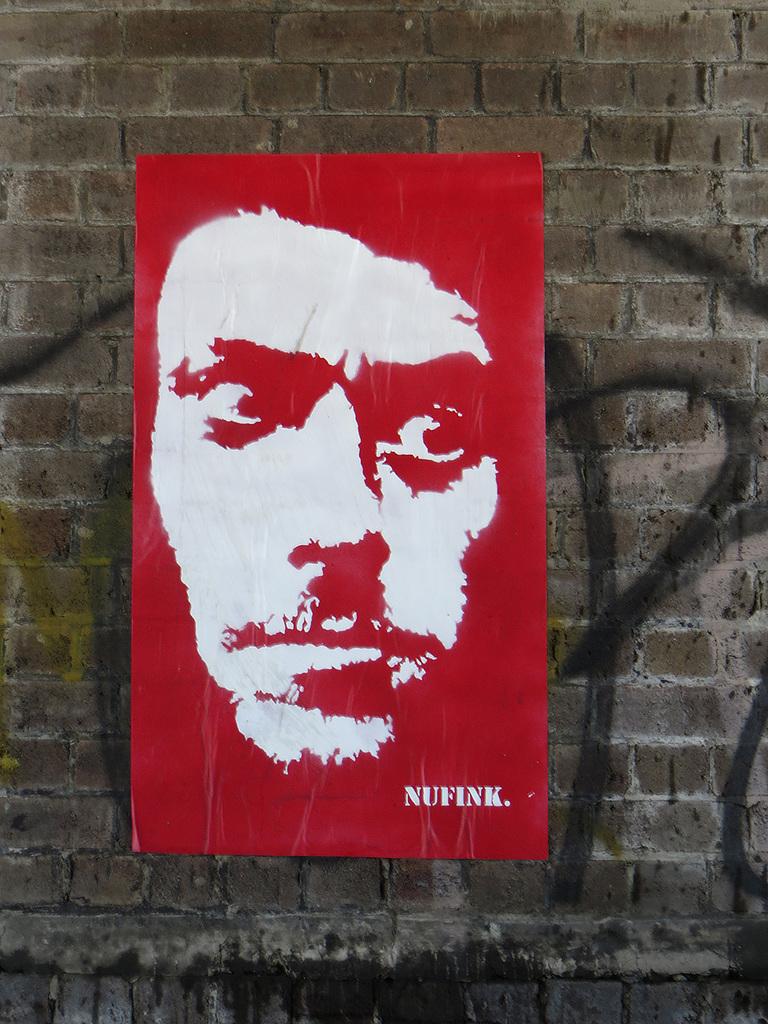What is written on the bottom?
Provide a short and direct response. Nufink. 